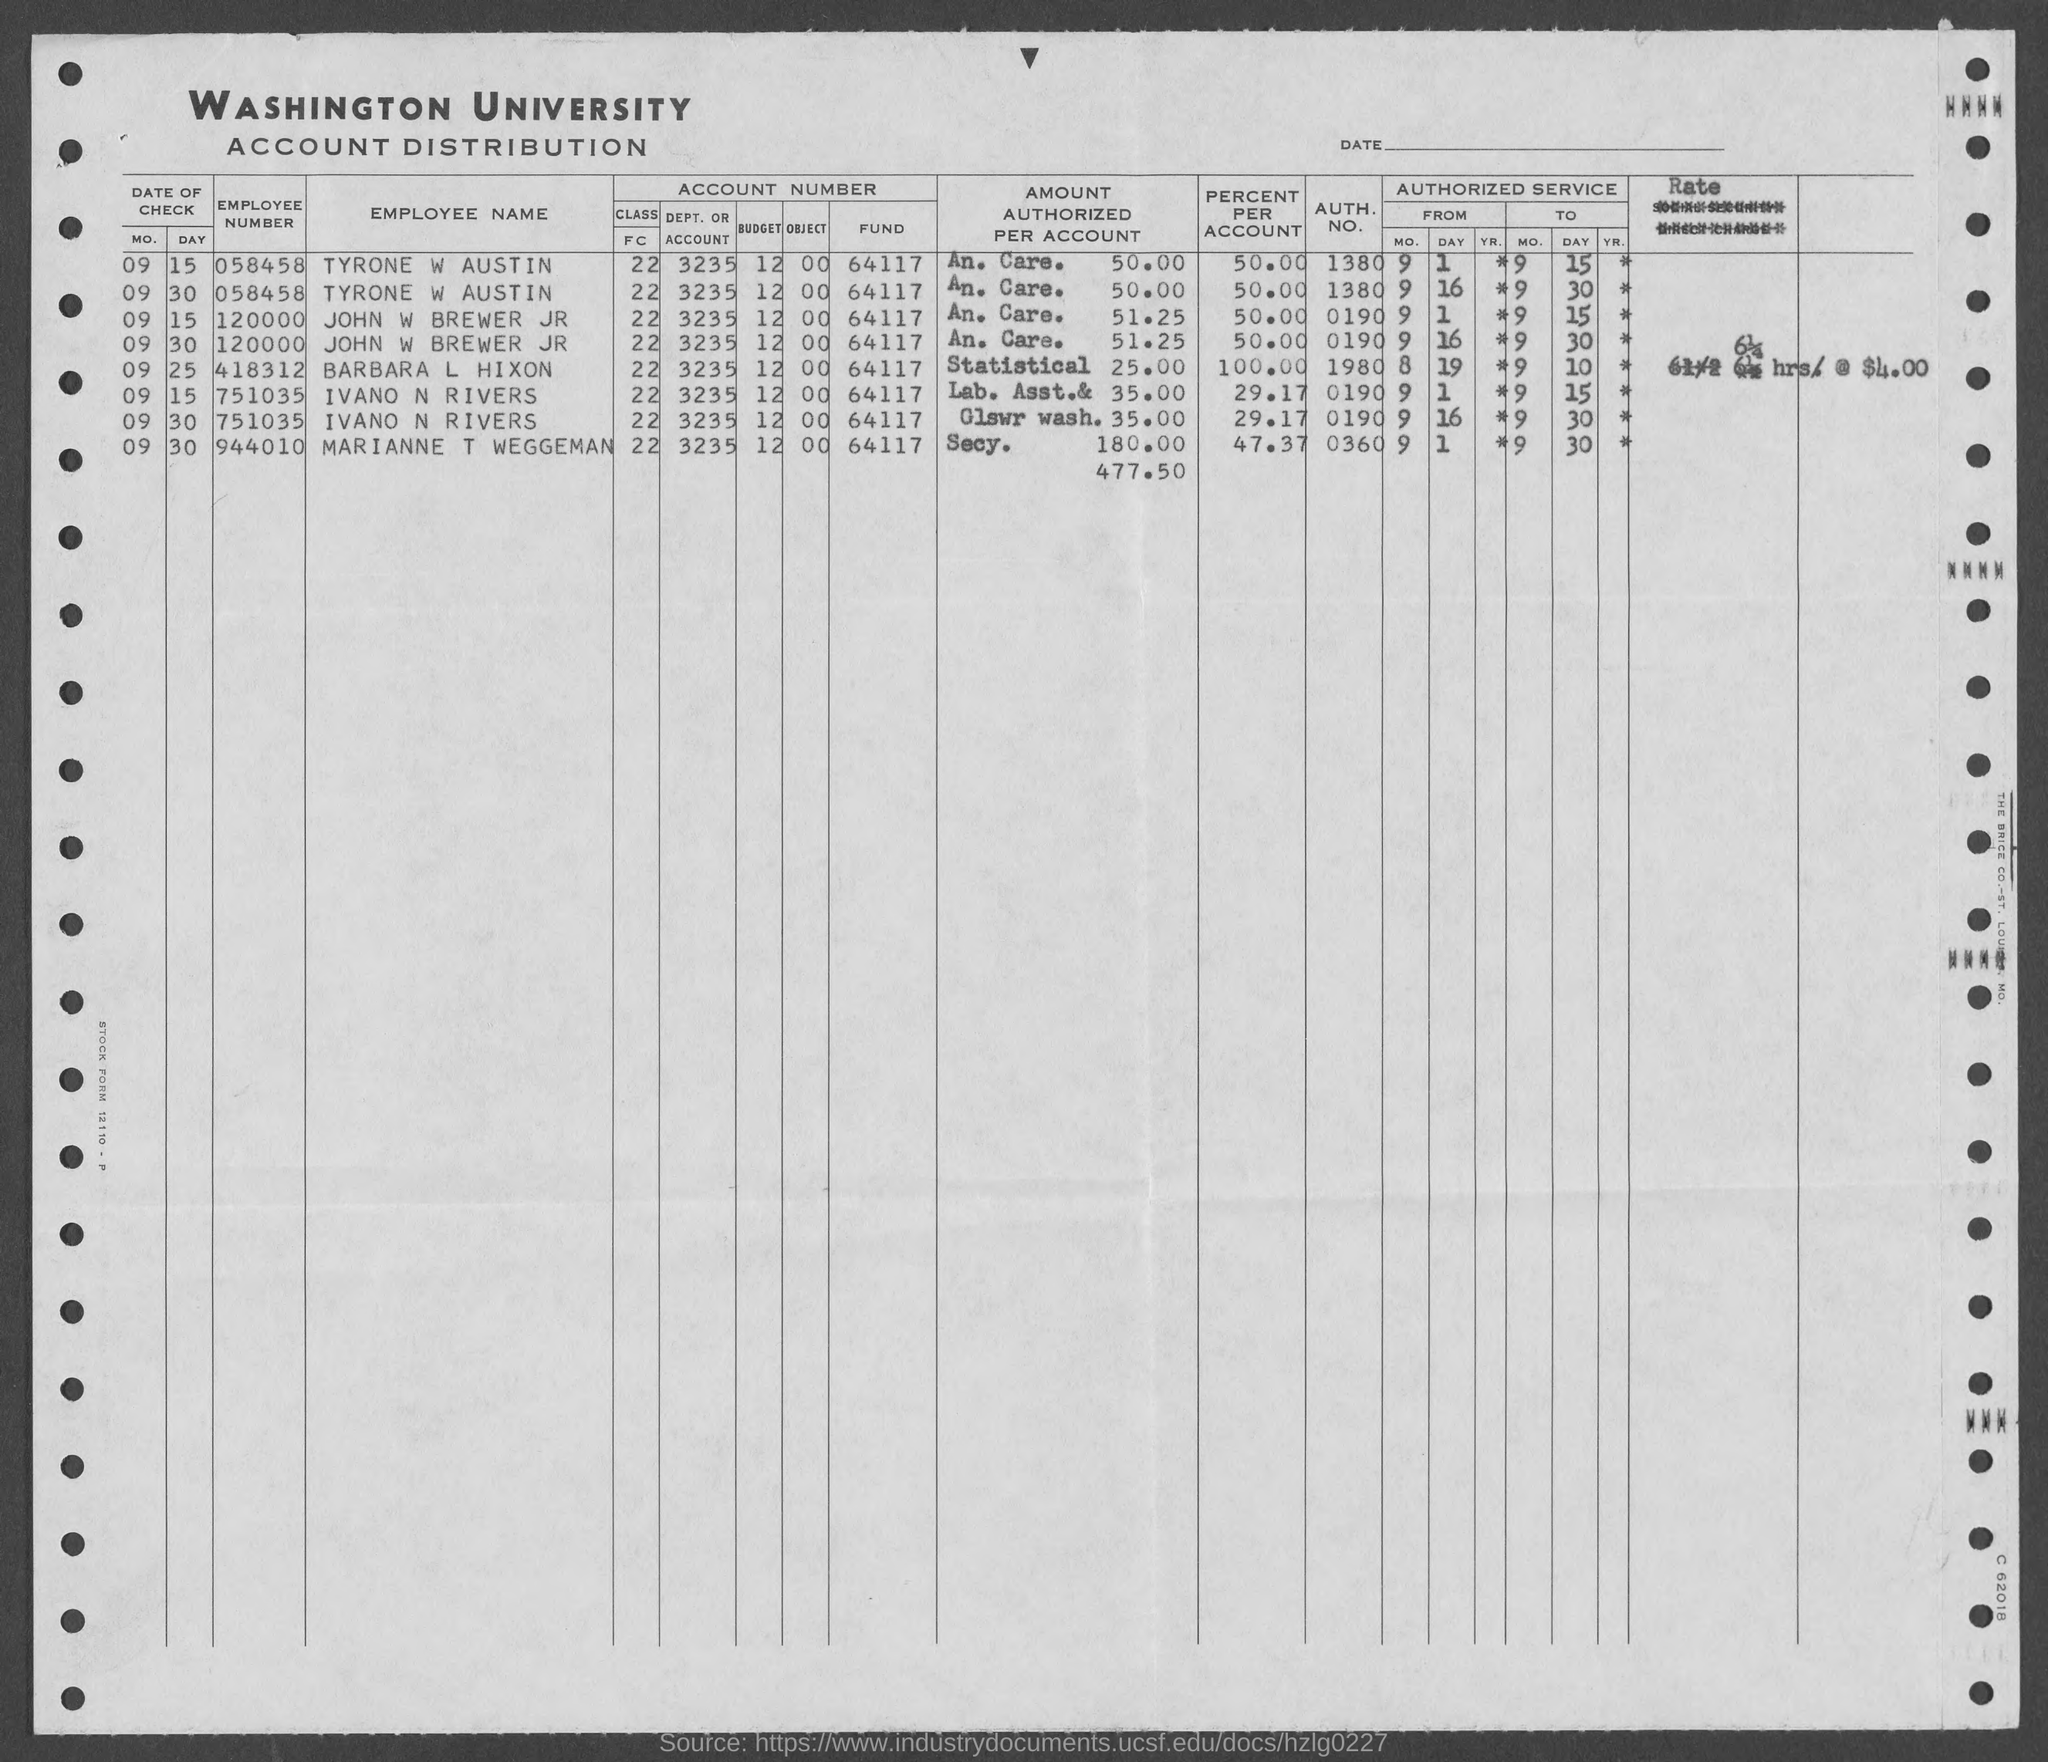Mention a couple of crucial points in this snapshot. The employee number of Ivano N Rivers is 751035... The authentication number of Marianne T Weggeman is 0360. The authorization number of Ivano N. Rivers is 0190. Barbara L Hixon's employee number is 418312. The employee number of John W Brewer Jr is 120000. 